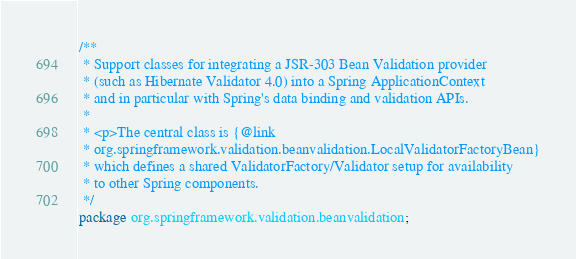<code> <loc_0><loc_0><loc_500><loc_500><_Java_>/**
 * Support classes for integrating a JSR-303 Bean Validation provider
 * (such as Hibernate Validator 4.0) into a Spring ApplicationContext
 * and in particular with Spring's data binding and validation APIs.
 *
 * <p>The central class is {@link
 * org.springframework.validation.beanvalidation.LocalValidatorFactoryBean}
 * which defines a shared ValidatorFactory/Validator setup for availability
 * to other Spring components.
 */
package org.springframework.validation.beanvalidation;
</code> 